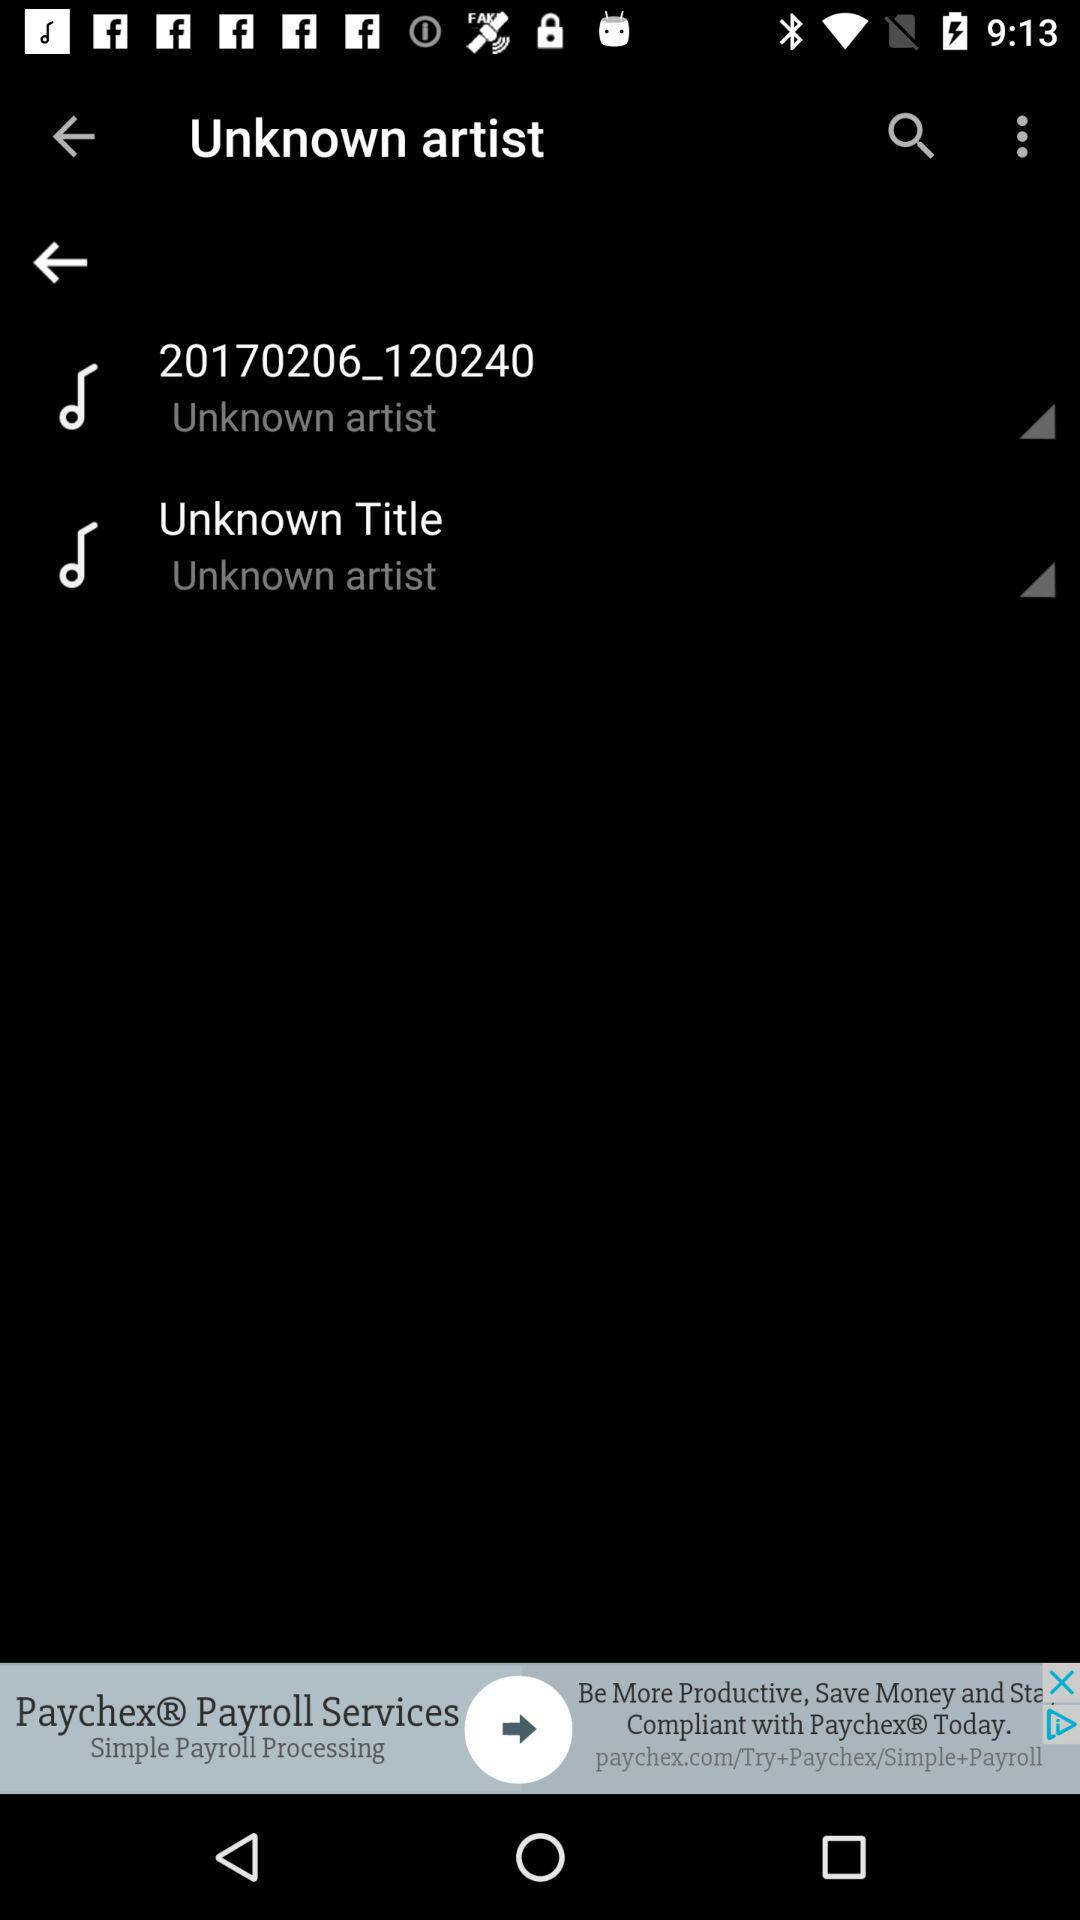How many items have the text 'Unknown artist'?
Answer the question using a single word or phrase. 2 